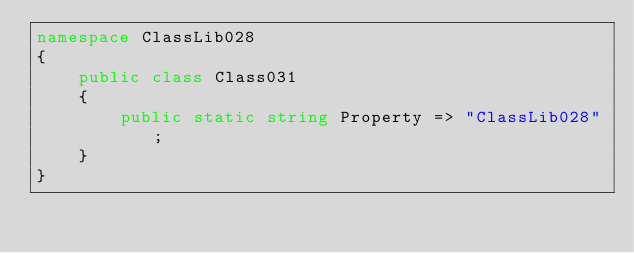<code> <loc_0><loc_0><loc_500><loc_500><_C#_>namespace ClassLib028
{
    public class Class031
    {
        public static string Property => "ClassLib028";
    }
}
</code> 